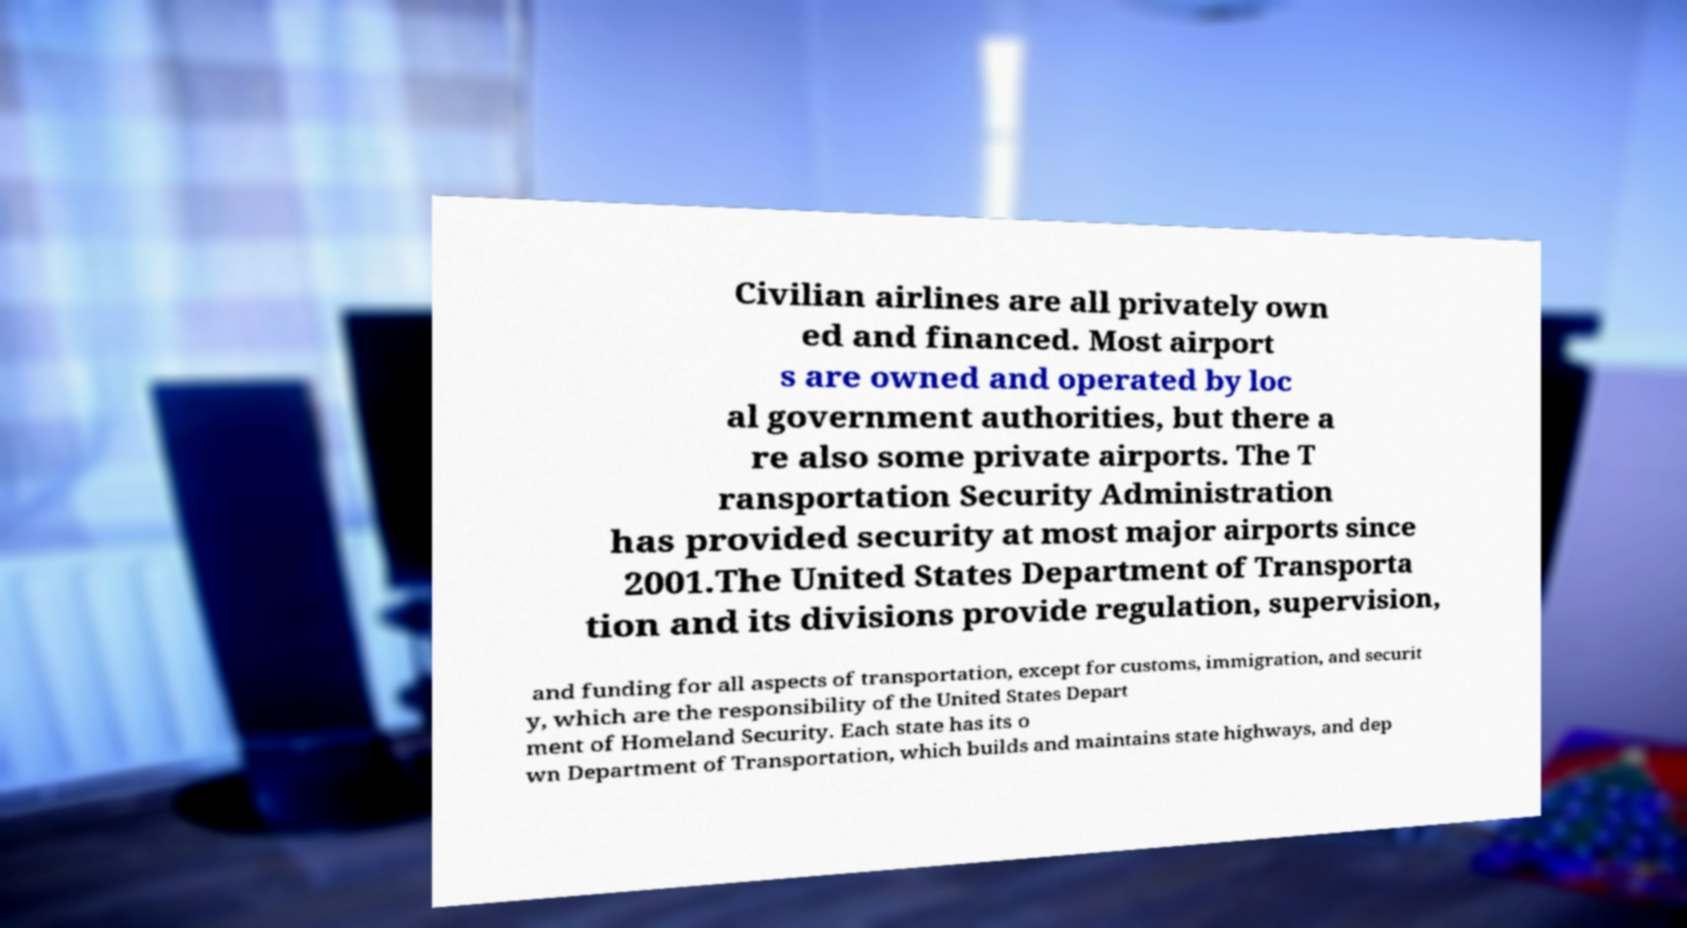Can you read and provide the text displayed in the image?This photo seems to have some interesting text. Can you extract and type it out for me? Civilian airlines are all privately own ed and financed. Most airport s are owned and operated by loc al government authorities, but there a re also some private airports. The T ransportation Security Administration has provided security at most major airports since 2001.The United States Department of Transporta tion and its divisions provide regulation, supervision, and funding for all aspects of transportation, except for customs, immigration, and securit y, which are the responsibility of the United States Depart ment of Homeland Security. Each state has its o wn Department of Transportation, which builds and maintains state highways, and dep 